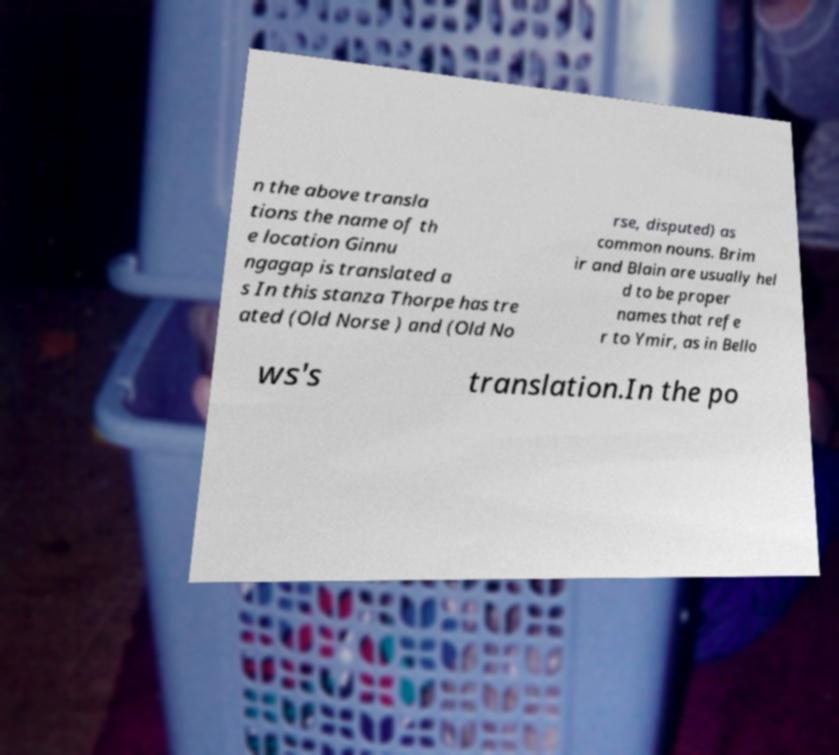Could you assist in decoding the text presented in this image and type it out clearly? n the above transla tions the name of th e location Ginnu ngagap is translated a s In this stanza Thorpe has tre ated (Old Norse ) and (Old No rse, disputed) as common nouns. Brim ir and Blain are usually hel d to be proper names that refe r to Ymir, as in Bello ws's translation.In the po 